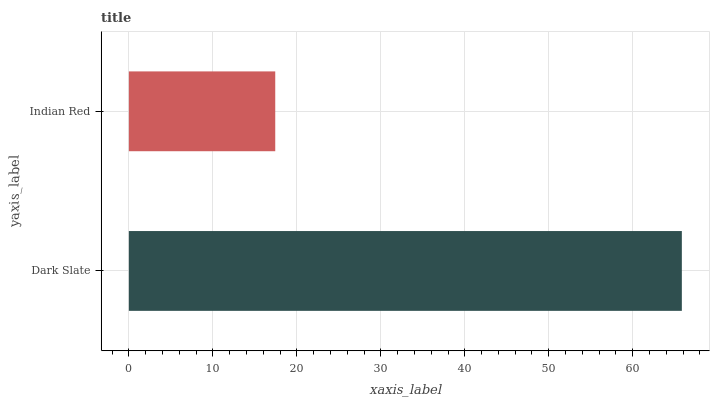Is Indian Red the minimum?
Answer yes or no. Yes. Is Dark Slate the maximum?
Answer yes or no. Yes. Is Indian Red the maximum?
Answer yes or no. No. Is Dark Slate greater than Indian Red?
Answer yes or no. Yes. Is Indian Red less than Dark Slate?
Answer yes or no. Yes. Is Indian Red greater than Dark Slate?
Answer yes or no. No. Is Dark Slate less than Indian Red?
Answer yes or no. No. Is Dark Slate the high median?
Answer yes or no. Yes. Is Indian Red the low median?
Answer yes or no. Yes. Is Indian Red the high median?
Answer yes or no. No. Is Dark Slate the low median?
Answer yes or no. No. 